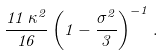Convert formula to latex. <formula><loc_0><loc_0><loc_500><loc_500>\frac { 1 1 \, \kappa ^ { 2 } } { 1 6 } \left ( 1 - \frac { \sigma ^ { 2 } } { 3 } \right ) ^ { - 1 } .</formula> 